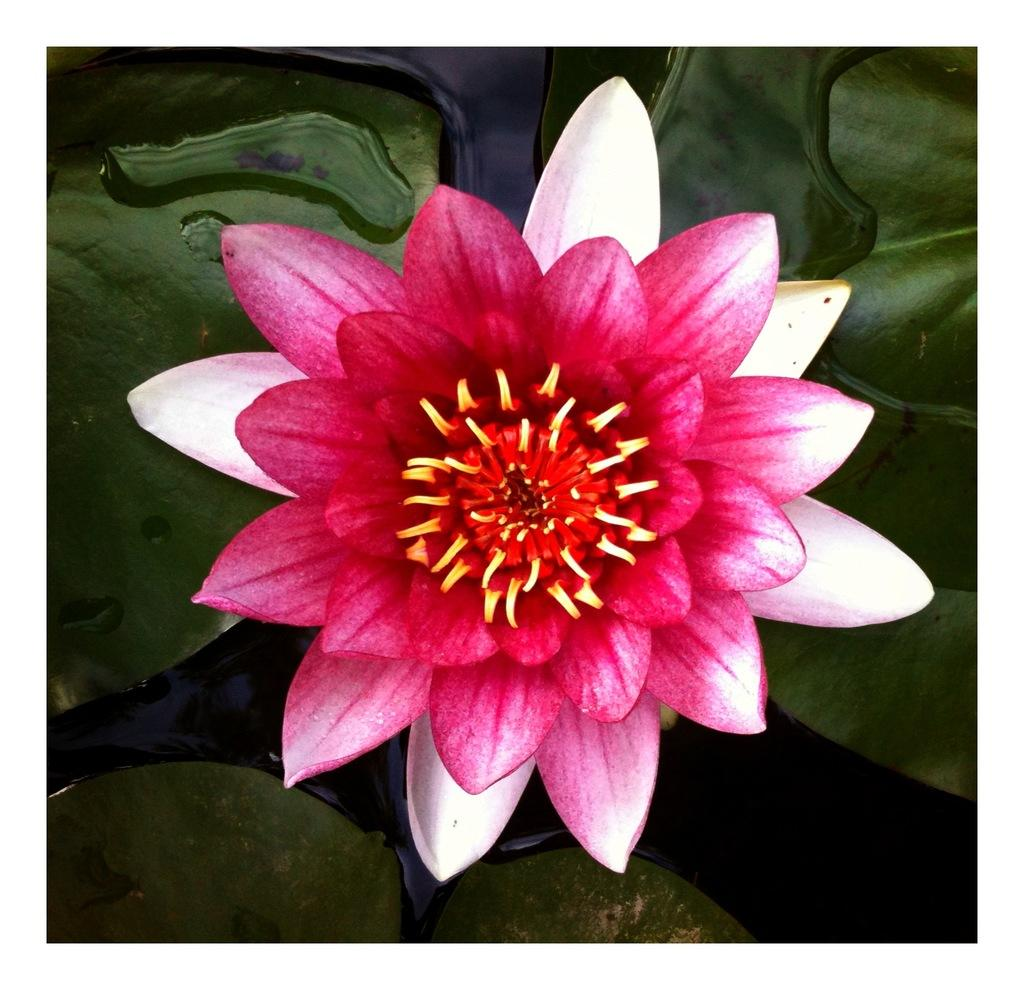What type of plant can be seen in the image? There is a flower in the image. What else can be seen in the water in the image? There are a few leaves visible in the water in the image. How many balls are being played with in the image? There are no balls present in the image. What type of fowl can be seen swimming in the water in the image? There are no fowl visible in the image; it only features a flower and leaves in the water. 